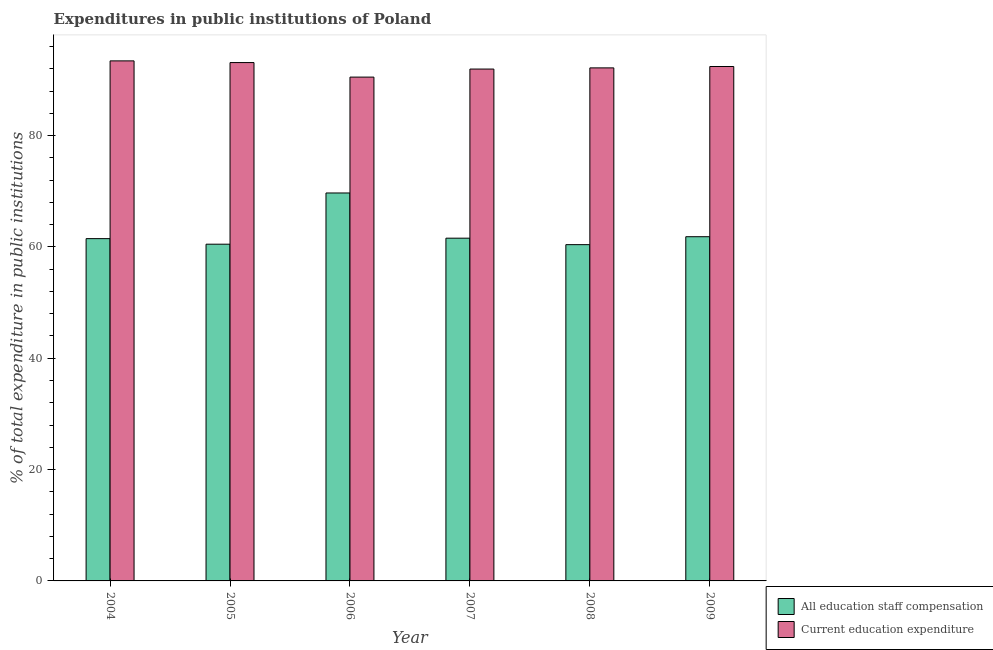Are the number of bars per tick equal to the number of legend labels?
Your answer should be very brief. Yes. How many bars are there on the 6th tick from the left?
Your answer should be very brief. 2. In how many cases, is the number of bars for a given year not equal to the number of legend labels?
Provide a succinct answer. 0. What is the expenditure in education in 2008?
Provide a short and direct response. 92.17. Across all years, what is the maximum expenditure in education?
Offer a very short reply. 93.43. Across all years, what is the minimum expenditure in staff compensation?
Your response must be concise. 60.41. In which year was the expenditure in staff compensation maximum?
Make the answer very short. 2006. What is the total expenditure in education in the graph?
Your answer should be compact. 553.59. What is the difference between the expenditure in staff compensation in 2004 and that in 2005?
Make the answer very short. 1. What is the difference between the expenditure in education in 2005 and the expenditure in staff compensation in 2004?
Give a very brief answer. -0.31. What is the average expenditure in education per year?
Ensure brevity in your answer.  92.27. In how many years, is the expenditure in education greater than 64 %?
Give a very brief answer. 6. What is the ratio of the expenditure in education in 2004 to that in 2006?
Keep it short and to the point. 1.03. Is the difference between the expenditure in education in 2007 and 2008 greater than the difference between the expenditure in staff compensation in 2007 and 2008?
Your answer should be very brief. No. What is the difference between the highest and the second highest expenditure in staff compensation?
Your answer should be very brief. 7.86. What is the difference between the highest and the lowest expenditure in education?
Provide a short and direct response. 2.92. In how many years, is the expenditure in education greater than the average expenditure in education taken over all years?
Provide a succinct answer. 3. What does the 2nd bar from the left in 2007 represents?
Your answer should be very brief. Current education expenditure. What does the 1st bar from the right in 2008 represents?
Provide a succinct answer. Current education expenditure. What is the difference between two consecutive major ticks on the Y-axis?
Offer a very short reply. 20. Are the values on the major ticks of Y-axis written in scientific E-notation?
Keep it short and to the point. No. Does the graph contain any zero values?
Keep it short and to the point. No. Where does the legend appear in the graph?
Your answer should be very brief. Bottom right. How many legend labels are there?
Offer a terse response. 2. What is the title of the graph?
Your answer should be compact. Expenditures in public institutions of Poland. Does "Taxes on profits and capital gains" appear as one of the legend labels in the graph?
Your answer should be compact. No. What is the label or title of the Y-axis?
Keep it short and to the point. % of total expenditure in public institutions. What is the % of total expenditure in public institutions of All education staff compensation in 2004?
Give a very brief answer. 61.49. What is the % of total expenditure in public institutions of Current education expenditure in 2004?
Offer a terse response. 93.43. What is the % of total expenditure in public institutions of All education staff compensation in 2005?
Offer a very short reply. 60.49. What is the % of total expenditure in public institutions of Current education expenditure in 2005?
Ensure brevity in your answer.  93.12. What is the % of total expenditure in public institutions of All education staff compensation in 2006?
Offer a very short reply. 69.7. What is the % of total expenditure in public institutions in Current education expenditure in 2006?
Ensure brevity in your answer.  90.51. What is the % of total expenditure in public institutions in All education staff compensation in 2007?
Ensure brevity in your answer.  61.57. What is the % of total expenditure in public institutions in Current education expenditure in 2007?
Your answer should be very brief. 91.96. What is the % of total expenditure in public institutions in All education staff compensation in 2008?
Make the answer very short. 60.41. What is the % of total expenditure in public institutions in Current education expenditure in 2008?
Offer a terse response. 92.17. What is the % of total expenditure in public institutions of All education staff compensation in 2009?
Keep it short and to the point. 61.84. What is the % of total expenditure in public institutions in Current education expenditure in 2009?
Your answer should be compact. 92.41. Across all years, what is the maximum % of total expenditure in public institutions of All education staff compensation?
Give a very brief answer. 69.7. Across all years, what is the maximum % of total expenditure in public institutions in Current education expenditure?
Your response must be concise. 93.43. Across all years, what is the minimum % of total expenditure in public institutions in All education staff compensation?
Your answer should be compact. 60.41. Across all years, what is the minimum % of total expenditure in public institutions in Current education expenditure?
Your response must be concise. 90.51. What is the total % of total expenditure in public institutions in All education staff compensation in the graph?
Your answer should be very brief. 375.5. What is the total % of total expenditure in public institutions of Current education expenditure in the graph?
Your answer should be very brief. 553.59. What is the difference between the % of total expenditure in public institutions of Current education expenditure in 2004 and that in 2005?
Make the answer very short. 0.31. What is the difference between the % of total expenditure in public institutions in All education staff compensation in 2004 and that in 2006?
Keep it short and to the point. -8.2. What is the difference between the % of total expenditure in public institutions of Current education expenditure in 2004 and that in 2006?
Offer a very short reply. 2.92. What is the difference between the % of total expenditure in public institutions of All education staff compensation in 2004 and that in 2007?
Your answer should be compact. -0.08. What is the difference between the % of total expenditure in public institutions in Current education expenditure in 2004 and that in 2007?
Your answer should be compact. 1.47. What is the difference between the % of total expenditure in public institutions in All education staff compensation in 2004 and that in 2008?
Your answer should be compact. 1.08. What is the difference between the % of total expenditure in public institutions of Current education expenditure in 2004 and that in 2008?
Offer a terse response. 1.26. What is the difference between the % of total expenditure in public institutions in All education staff compensation in 2004 and that in 2009?
Your answer should be very brief. -0.34. What is the difference between the % of total expenditure in public institutions in Current education expenditure in 2004 and that in 2009?
Make the answer very short. 1.01. What is the difference between the % of total expenditure in public institutions in All education staff compensation in 2005 and that in 2006?
Offer a very short reply. -9.2. What is the difference between the % of total expenditure in public institutions in Current education expenditure in 2005 and that in 2006?
Make the answer very short. 2.61. What is the difference between the % of total expenditure in public institutions in All education staff compensation in 2005 and that in 2007?
Your answer should be compact. -1.08. What is the difference between the % of total expenditure in public institutions in Current education expenditure in 2005 and that in 2007?
Your answer should be very brief. 1.16. What is the difference between the % of total expenditure in public institutions of All education staff compensation in 2005 and that in 2008?
Give a very brief answer. 0.08. What is the difference between the % of total expenditure in public institutions in Current education expenditure in 2005 and that in 2008?
Make the answer very short. 0.95. What is the difference between the % of total expenditure in public institutions of All education staff compensation in 2005 and that in 2009?
Your answer should be compact. -1.34. What is the difference between the % of total expenditure in public institutions in Current education expenditure in 2005 and that in 2009?
Provide a short and direct response. 0.71. What is the difference between the % of total expenditure in public institutions of All education staff compensation in 2006 and that in 2007?
Offer a very short reply. 8.12. What is the difference between the % of total expenditure in public institutions in Current education expenditure in 2006 and that in 2007?
Your answer should be compact. -1.45. What is the difference between the % of total expenditure in public institutions in All education staff compensation in 2006 and that in 2008?
Make the answer very short. 9.28. What is the difference between the % of total expenditure in public institutions of Current education expenditure in 2006 and that in 2008?
Provide a succinct answer. -1.66. What is the difference between the % of total expenditure in public institutions of All education staff compensation in 2006 and that in 2009?
Make the answer very short. 7.86. What is the difference between the % of total expenditure in public institutions in Current education expenditure in 2006 and that in 2009?
Your answer should be very brief. -1.9. What is the difference between the % of total expenditure in public institutions of All education staff compensation in 2007 and that in 2008?
Make the answer very short. 1.16. What is the difference between the % of total expenditure in public institutions of Current education expenditure in 2007 and that in 2008?
Keep it short and to the point. -0.21. What is the difference between the % of total expenditure in public institutions in All education staff compensation in 2007 and that in 2009?
Your answer should be compact. -0.26. What is the difference between the % of total expenditure in public institutions in Current education expenditure in 2007 and that in 2009?
Provide a short and direct response. -0.46. What is the difference between the % of total expenditure in public institutions in All education staff compensation in 2008 and that in 2009?
Ensure brevity in your answer.  -1.42. What is the difference between the % of total expenditure in public institutions in Current education expenditure in 2008 and that in 2009?
Provide a short and direct response. -0.25. What is the difference between the % of total expenditure in public institutions in All education staff compensation in 2004 and the % of total expenditure in public institutions in Current education expenditure in 2005?
Give a very brief answer. -31.63. What is the difference between the % of total expenditure in public institutions in All education staff compensation in 2004 and the % of total expenditure in public institutions in Current education expenditure in 2006?
Provide a succinct answer. -29.02. What is the difference between the % of total expenditure in public institutions in All education staff compensation in 2004 and the % of total expenditure in public institutions in Current education expenditure in 2007?
Keep it short and to the point. -30.47. What is the difference between the % of total expenditure in public institutions in All education staff compensation in 2004 and the % of total expenditure in public institutions in Current education expenditure in 2008?
Give a very brief answer. -30.68. What is the difference between the % of total expenditure in public institutions of All education staff compensation in 2004 and the % of total expenditure in public institutions of Current education expenditure in 2009?
Provide a succinct answer. -30.92. What is the difference between the % of total expenditure in public institutions of All education staff compensation in 2005 and the % of total expenditure in public institutions of Current education expenditure in 2006?
Your response must be concise. -30.02. What is the difference between the % of total expenditure in public institutions of All education staff compensation in 2005 and the % of total expenditure in public institutions of Current education expenditure in 2007?
Keep it short and to the point. -31.47. What is the difference between the % of total expenditure in public institutions of All education staff compensation in 2005 and the % of total expenditure in public institutions of Current education expenditure in 2008?
Your answer should be very brief. -31.67. What is the difference between the % of total expenditure in public institutions of All education staff compensation in 2005 and the % of total expenditure in public institutions of Current education expenditure in 2009?
Make the answer very short. -31.92. What is the difference between the % of total expenditure in public institutions of All education staff compensation in 2006 and the % of total expenditure in public institutions of Current education expenditure in 2007?
Offer a terse response. -22.26. What is the difference between the % of total expenditure in public institutions in All education staff compensation in 2006 and the % of total expenditure in public institutions in Current education expenditure in 2008?
Make the answer very short. -22.47. What is the difference between the % of total expenditure in public institutions of All education staff compensation in 2006 and the % of total expenditure in public institutions of Current education expenditure in 2009?
Provide a succinct answer. -22.72. What is the difference between the % of total expenditure in public institutions of All education staff compensation in 2007 and the % of total expenditure in public institutions of Current education expenditure in 2008?
Provide a short and direct response. -30.59. What is the difference between the % of total expenditure in public institutions of All education staff compensation in 2007 and the % of total expenditure in public institutions of Current education expenditure in 2009?
Offer a terse response. -30.84. What is the difference between the % of total expenditure in public institutions in All education staff compensation in 2008 and the % of total expenditure in public institutions in Current education expenditure in 2009?
Ensure brevity in your answer.  -32. What is the average % of total expenditure in public institutions in All education staff compensation per year?
Offer a very short reply. 62.58. What is the average % of total expenditure in public institutions of Current education expenditure per year?
Your answer should be compact. 92.27. In the year 2004, what is the difference between the % of total expenditure in public institutions of All education staff compensation and % of total expenditure in public institutions of Current education expenditure?
Provide a succinct answer. -31.93. In the year 2005, what is the difference between the % of total expenditure in public institutions of All education staff compensation and % of total expenditure in public institutions of Current education expenditure?
Offer a terse response. -32.63. In the year 2006, what is the difference between the % of total expenditure in public institutions in All education staff compensation and % of total expenditure in public institutions in Current education expenditure?
Provide a short and direct response. -20.81. In the year 2007, what is the difference between the % of total expenditure in public institutions in All education staff compensation and % of total expenditure in public institutions in Current education expenditure?
Keep it short and to the point. -30.38. In the year 2008, what is the difference between the % of total expenditure in public institutions of All education staff compensation and % of total expenditure in public institutions of Current education expenditure?
Your answer should be very brief. -31.75. In the year 2009, what is the difference between the % of total expenditure in public institutions in All education staff compensation and % of total expenditure in public institutions in Current education expenditure?
Provide a short and direct response. -30.58. What is the ratio of the % of total expenditure in public institutions in All education staff compensation in 2004 to that in 2005?
Your response must be concise. 1.02. What is the ratio of the % of total expenditure in public institutions in All education staff compensation in 2004 to that in 2006?
Ensure brevity in your answer.  0.88. What is the ratio of the % of total expenditure in public institutions in Current education expenditure in 2004 to that in 2006?
Ensure brevity in your answer.  1.03. What is the ratio of the % of total expenditure in public institutions of All education staff compensation in 2004 to that in 2008?
Your response must be concise. 1.02. What is the ratio of the % of total expenditure in public institutions in Current education expenditure in 2004 to that in 2008?
Keep it short and to the point. 1.01. What is the ratio of the % of total expenditure in public institutions of All education staff compensation in 2004 to that in 2009?
Provide a succinct answer. 0.99. What is the ratio of the % of total expenditure in public institutions of Current education expenditure in 2004 to that in 2009?
Provide a short and direct response. 1.01. What is the ratio of the % of total expenditure in public institutions of All education staff compensation in 2005 to that in 2006?
Your answer should be very brief. 0.87. What is the ratio of the % of total expenditure in public institutions in Current education expenditure in 2005 to that in 2006?
Give a very brief answer. 1.03. What is the ratio of the % of total expenditure in public institutions of All education staff compensation in 2005 to that in 2007?
Offer a very short reply. 0.98. What is the ratio of the % of total expenditure in public institutions in Current education expenditure in 2005 to that in 2007?
Make the answer very short. 1.01. What is the ratio of the % of total expenditure in public institutions in Current education expenditure in 2005 to that in 2008?
Ensure brevity in your answer.  1.01. What is the ratio of the % of total expenditure in public institutions in All education staff compensation in 2005 to that in 2009?
Give a very brief answer. 0.98. What is the ratio of the % of total expenditure in public institutions of Current education expenditure in 2005 to that in 2009?
Give a very brief answer. 1.01. What is the ratio of the % of total expenditure in public institutions of All education staff compensation in 2006 to that in 2007?
Provide a short and direct response. 1.13. What is the ratio of the % of total expenditure in public institutions of Current education expenditure in 2006 to that in 2007?
Make the answer very short. 0.98. What is the ratio of the % of total expenditure in public institutions of All education staff compensation in 2006 to that in 2008?
Give a very brief answer. 1.15. What is the ratio of the % of total expenditure in public institutions in All education staff compensation in 2006 to that in 2009?
Keep it short and to the point. 1.13. What is the ratio of the % of total expenditure in public institutions of Current education expenditure in 2006 to that in 2009?
Your answer should be compact. 0.98. What is the ratio of the % of total expenditure in public institutions in All education staff compensation in 2007 to that in 2008?
Ensure brevity in your answer.  1.02. What is the ratio of the % of total expenditure in public institutions of Current education expenditure in 2007 to that in 2008?
Provide a succinct answer. 1. What is the ratio of the % of total expenditure in public institutions of All education staff compensation in 2007 to that in 2009?
Offer a terse response. 1. What is the ratio of the % of total expenditure in public institutions of Current education expenditure in 2007 to that in 2009?
Provide a short and direct response. 1. What is the ratio of the % of total expenditure in public institutions in All education staff compensation in 2008 to that in 2009?
Provide a succinct answer. 0.98. What is the difference between the highest and the second highest % of total expenditure in public institutions of All education staff compensation?
Keep it short and to the point. 7.86. What is the difference between the highest and the second highest % of total expenditure in public institutions in Current education expenditure?
Make the answer very short. 0.31. What is the difference between the highest and the lowest % of total expenditure in public institutions in All education staff compensation?
Your response must be concise. 9.28. What is the difference between the highest and the lowest % of total expenditure in public institutions of Current education expenditure?
Make the answer very short. 2.92. 